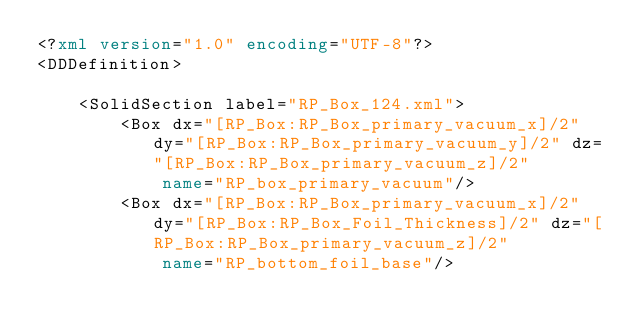Convert code to text. <code><loc_0><loc_0><loc_500><loc_500><_XML_><?xml version="1.0" encoding="UTF-8"?>
<DDDefinition>
    
    <SolidSection label="RP_Box_124.xml">
        <Box dx="[RP_Box:RP_Box_primary_vacuum_x]/2" dy="[RP_Box:RP_Box_primary_vacuum_y]/2" dz="[RP_Box:RP_Box_primary_vacuum_z]/2"
            name="RP_box_primary_vacuum"/>
        <Box dx="[RP_Box:RP_Box_primary_vacuum_x]/2" dy="[RP_Box:RP_Box_Foil_Thickness]/2" dz="[RP_Box:RP_Box_primary_vacuum_z]/2"
            name="RP_bottom_foil_base"/></code> 